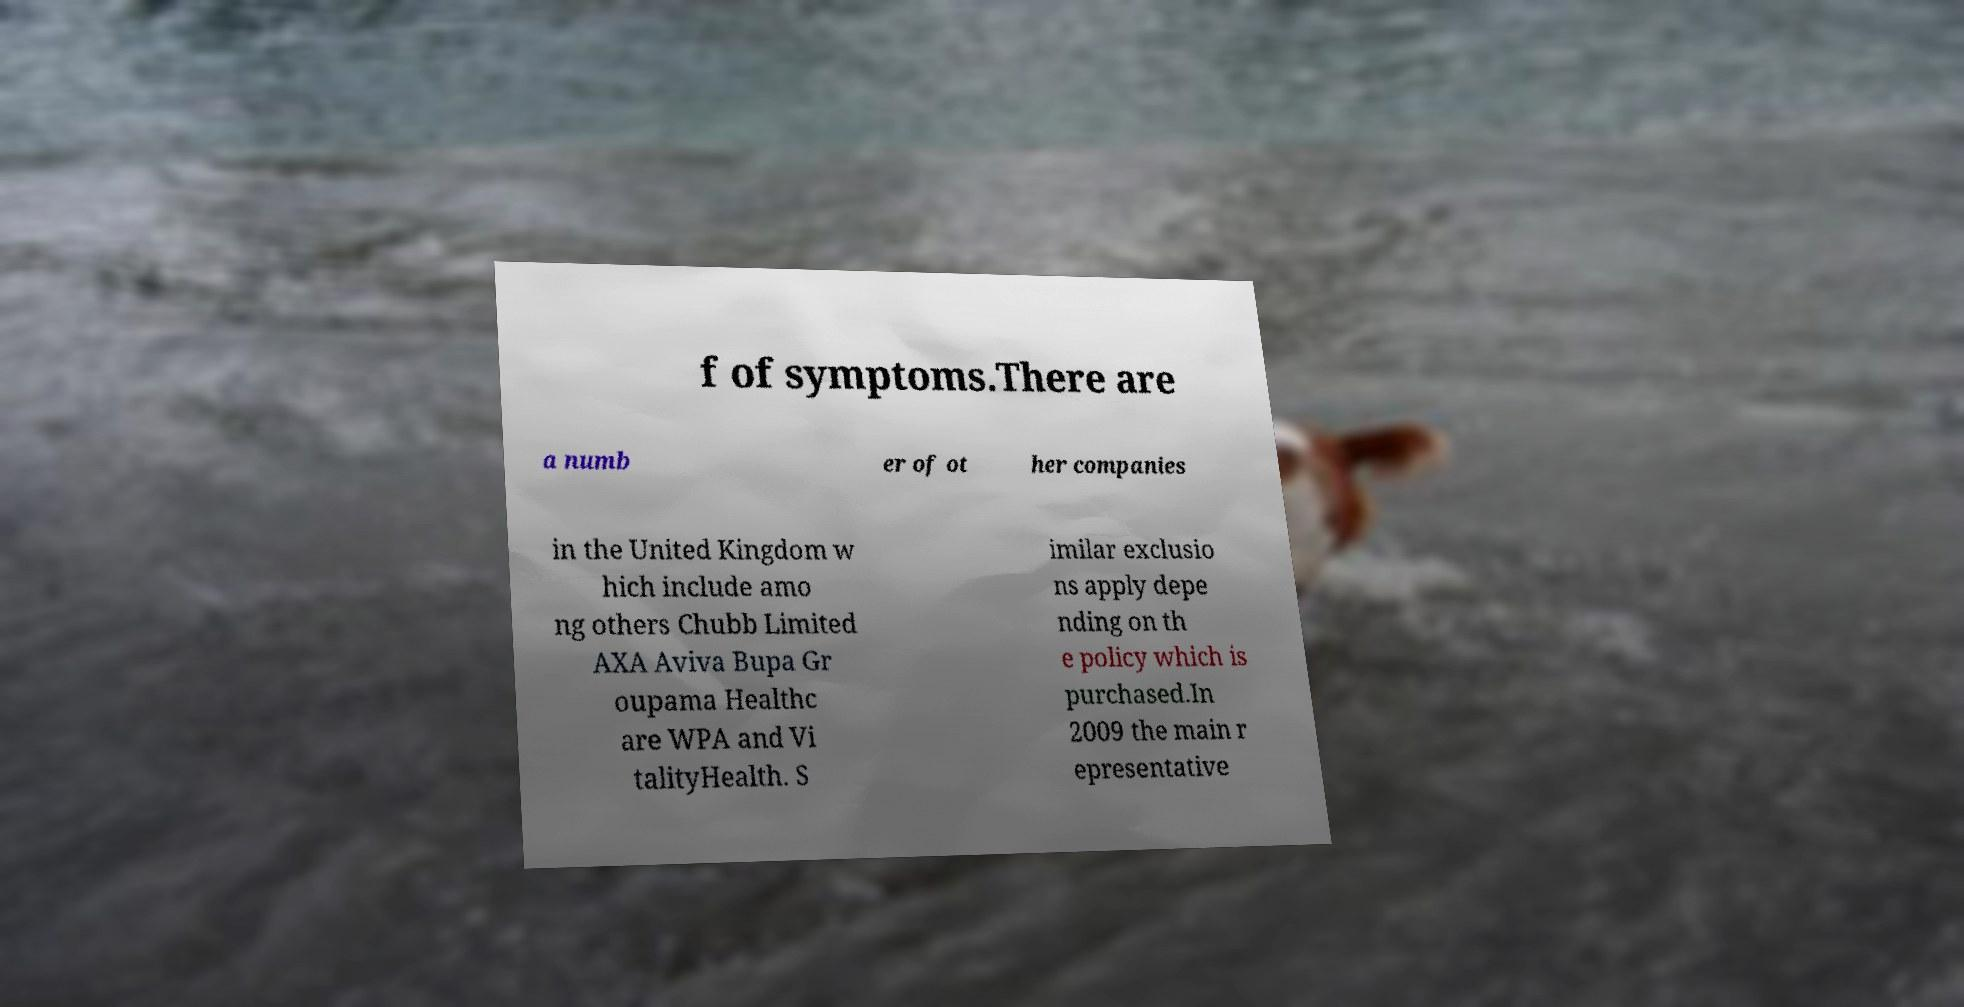Can you accurately transcribe the text from the provided image for me? f of symptoms.There are a numb er of ot her companies in the United Kingdom w hich include amo ng others Chubb Limited AXA Aviva Bupa Gr oupama Healthc are WPA and Vi talityHealth. S imilar exclusio ns apply depe nding on th e policy which is purchased.In 2009 the main r epresentative 